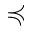Convert formula to latex. <formula><loc_0><loc_0><loc_500><loc_500>\prec c u r l y e q</formula> 